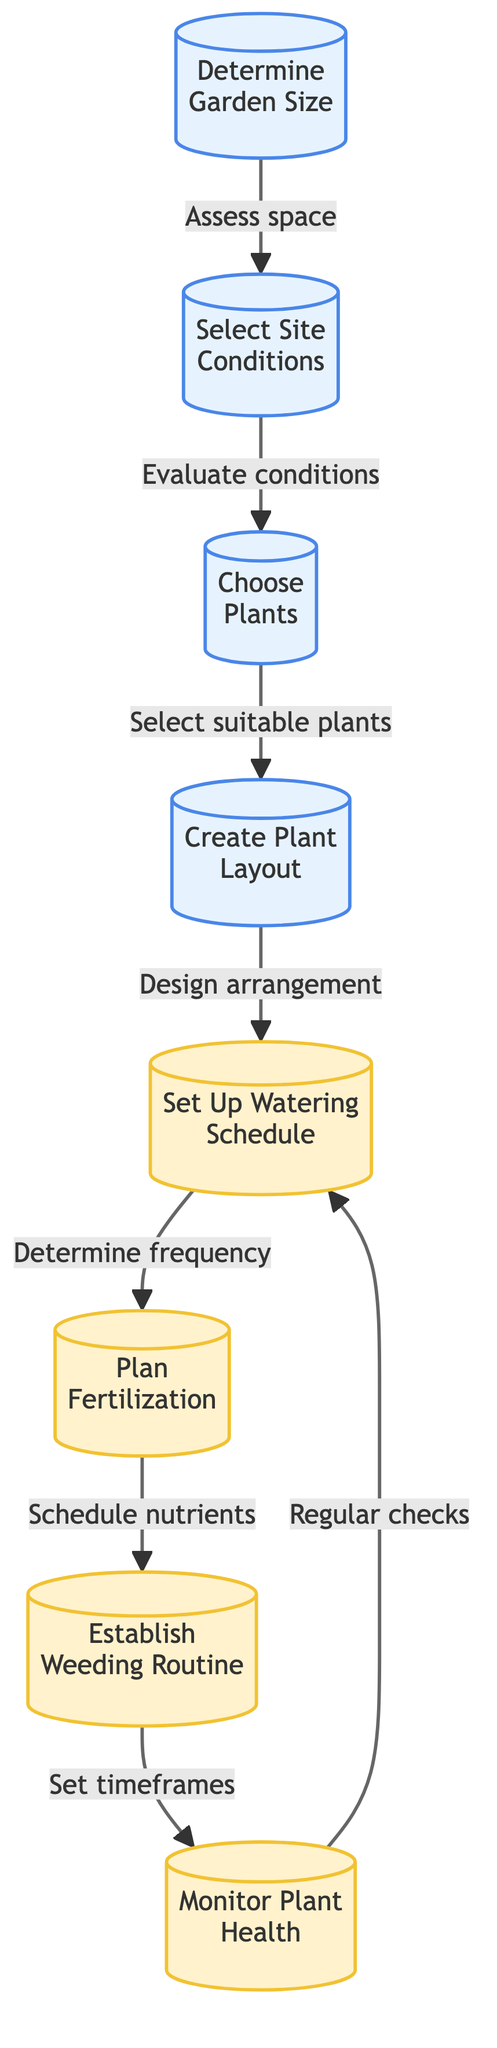What is the first step in the gardening project? The first step in the flow chart is "Determine Garden Size." This is depicted as the first node of the flowchart.
Answer: Determine Garden Size How many main steps are there in the gardening project? There are a total of eight main steps indicated in the flowchart, as there are eight nodes present in the diagram.
Answer: Eight Which step follows "Select Site Conditions"? The step that follows "Select Site Conditions" is "Choose Plants." This can be seen as a direct link from node 2 to node 3 in the flowchart.
Answer: Choose Plants What action is taken after creating the plant layout? After creating the plant layout, the next action is to "Set Up Watering Schedule," shown as the link directly following node 4.
Answer: Set Up Watering Schedule Which maintenance task is monitored regularly? The task monitored regularly is "Monitor Plant Health." This is indicated as the end node linked back to "Set Up Watering Schedule," indicating an ongoing process.
Answer: Monitor Plant Health What are the conditions to evaluate in step two? The conditions to evaluate in step two include sunlight exposure, soil quality, and drainage, as specified in the description of node 2.
Answer: Sunlight exposure, soil quality, drainage How many maintenance steps are included in this flowchart? There are four maintenance steps included in this flowchart: "Set Up Watering Schedule," "Plan Fertilization," "Establish Weeding Routine," and "Monitor Plant Health," making a total of four maintenance steps.
Answer: Four What describes the purpose of "Create Plant Layout"? The purpose of "Create Plant Layout" is to design the arrangement of chosen plants for optimal growth and aesthetics, as outlined in the description linked to node 4.
Answer: Design arrangement What follows the selection of suitable plants? Following the selection of suitable plants, the next step is "Create Plant Layout." This connects node 3 to node 4 in the flowchart.
Answer: Create Plant Layout 